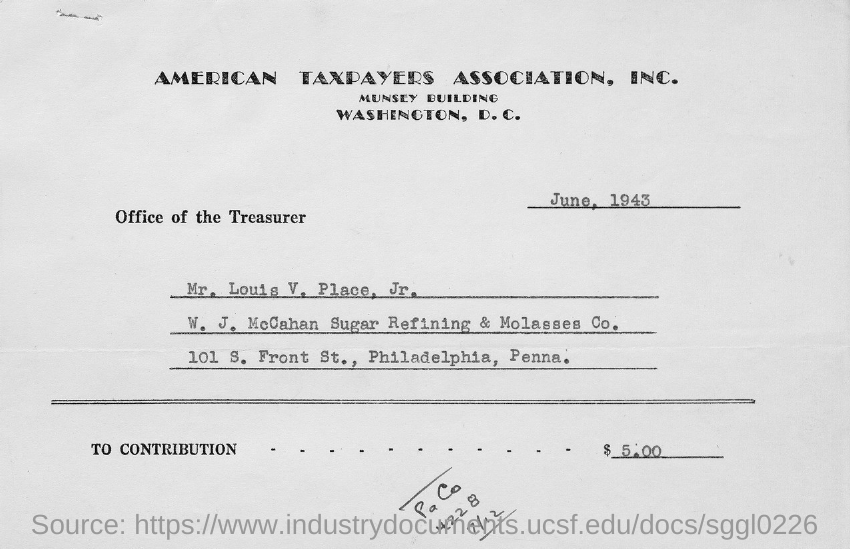What is the date on the document?
Offer a very short reply. JUNE, 1943. 